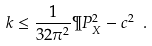Convert formula to latex. <formula><loc_0><loc_0><loc_500><loc_500>k \leq \frac { 1 } { 3 2 \pi ^ { 2 } } \P P _ { X } ^ { 2 } - c ^ { 2 } \ .</formula> 